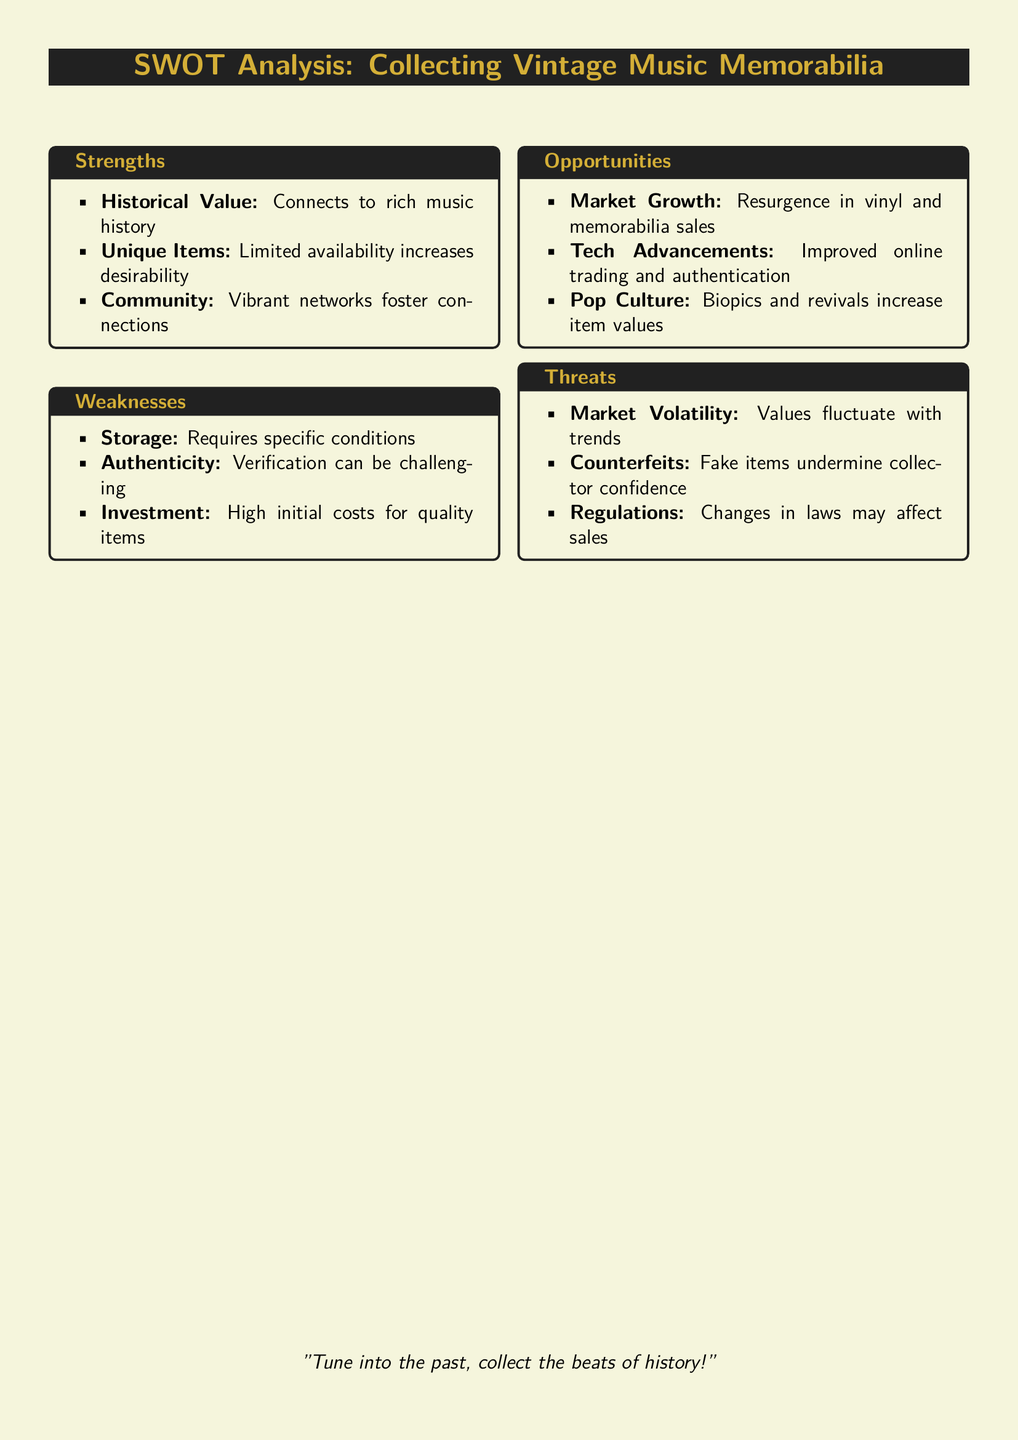What is one historical aspect of collecting vintage music memorabilia? The historical value connects to the rich music history, indicating its importance to collectors.
Answer: Historical Value What is a challenge related to the authenticity of items? Verification of authenticity can be challenging, making it harder for collectors to ensure item legitimacy.
Answer: Authenticity What trend is currently benefiting the vintage music memorabilia market? The market growth is seen as a resurgence in vinyl and memorabilia sales, suggesting increasing interest.
Answer: Market Growth What is a common concern regarding the storage of collectibles? Specific conditions are required for the storage, indicating that proper care is needed to maintain items.
Answer: Storage What fluctuates in the vintage music memorabilia market? Market volatility indicates that values fluctuate with trends, impacting the financial aspect for collectors.
Answer: Values What threat to collectors arises from counterfeit items? The existence of counterfeits undermines collector confidence, posing a risk to the authenticity perceived in the market.
Answer: Counterfeits Which innovation aids in improving the vintage memorabilia trading experience? Tech advancements benefit collectors through improved online trading and authentication methods.
Answer: Tech Advancements What do biopics and revivals do for item values? They increase item values, indicating a relationship between pop culture and collectible desirability.
Answer: Increase item values What is a major weakness regarding the investment in quality items? High initial costs are a concern, suggesting that entering the vintage music memorabilia market can be financially challenging.
Answer: High initial costs 